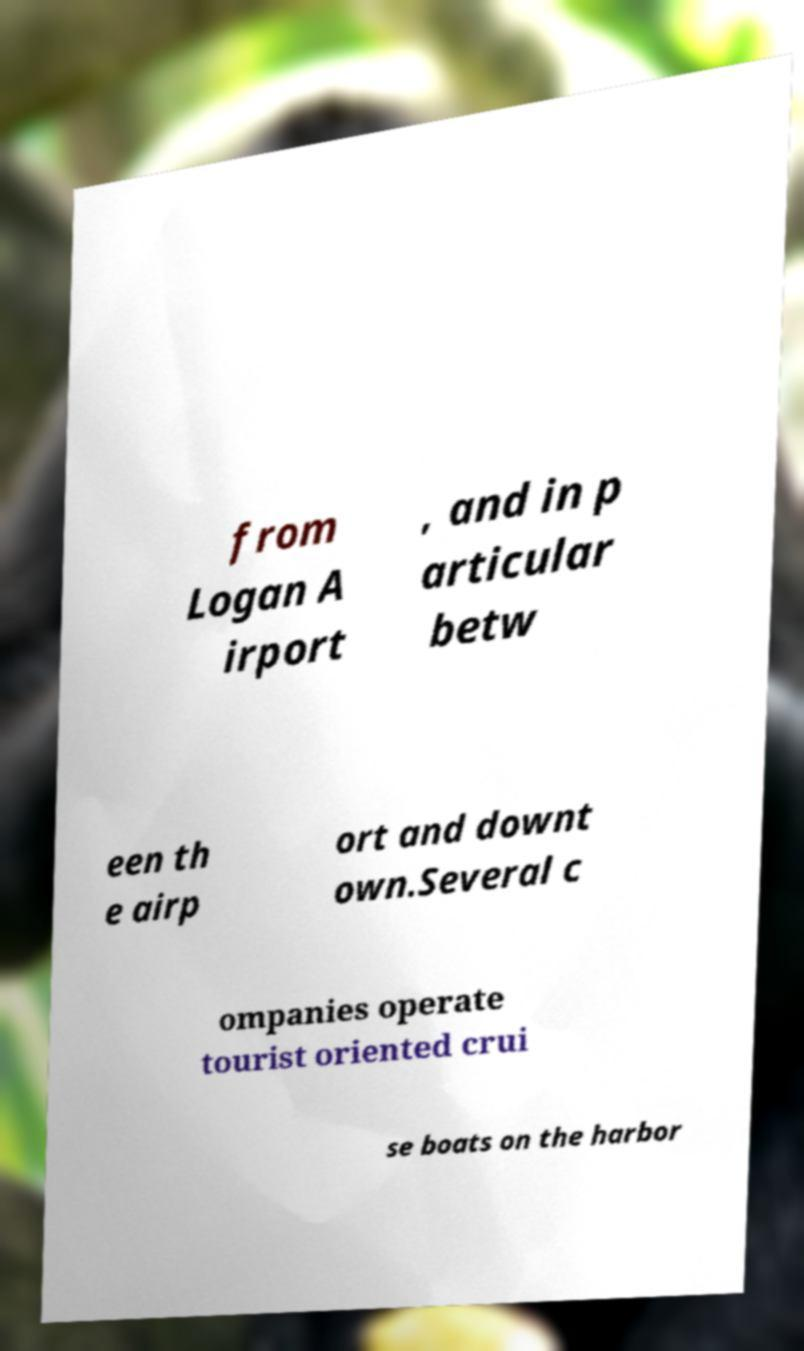Could you extract and type out the text from this image? from Logan A irport , and in p articular betw een th e airp ort and downt own.Several c ompanies operate tourist oriented crui se boats on the harbor 